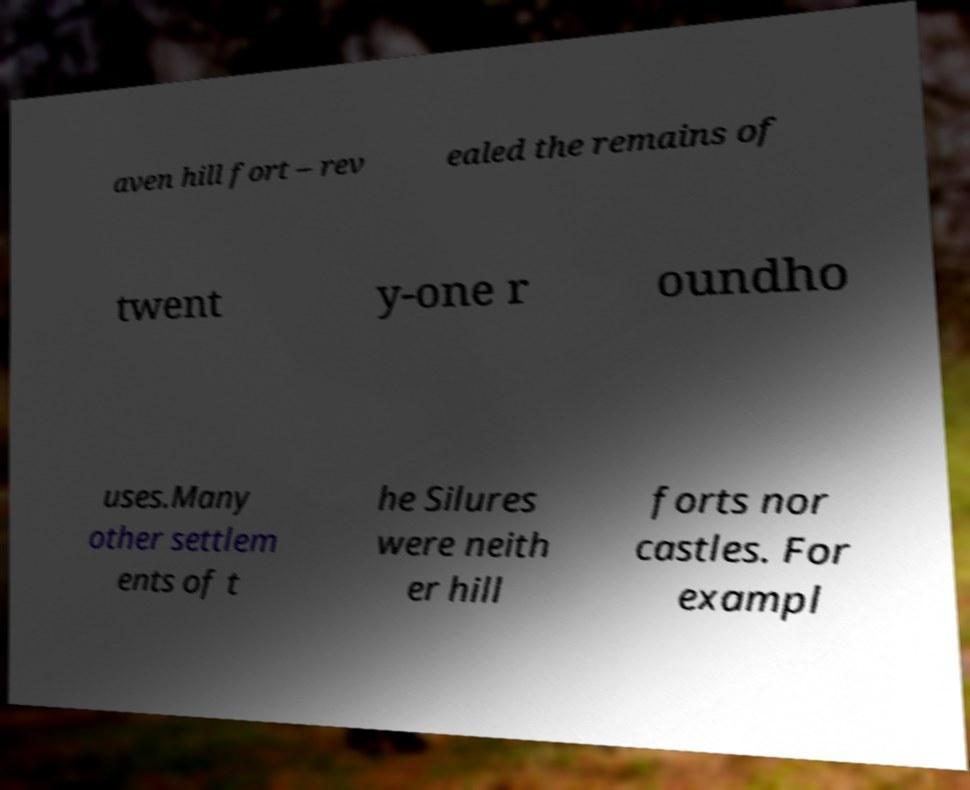What messages or text are displayed in this image? I need them in a readable, typed format. aven hill fort – rev ealed the remains of twent y-one r oundho uses.Many other settlem ents of t he Silures were neith er hill forts nor castles. For exampl 